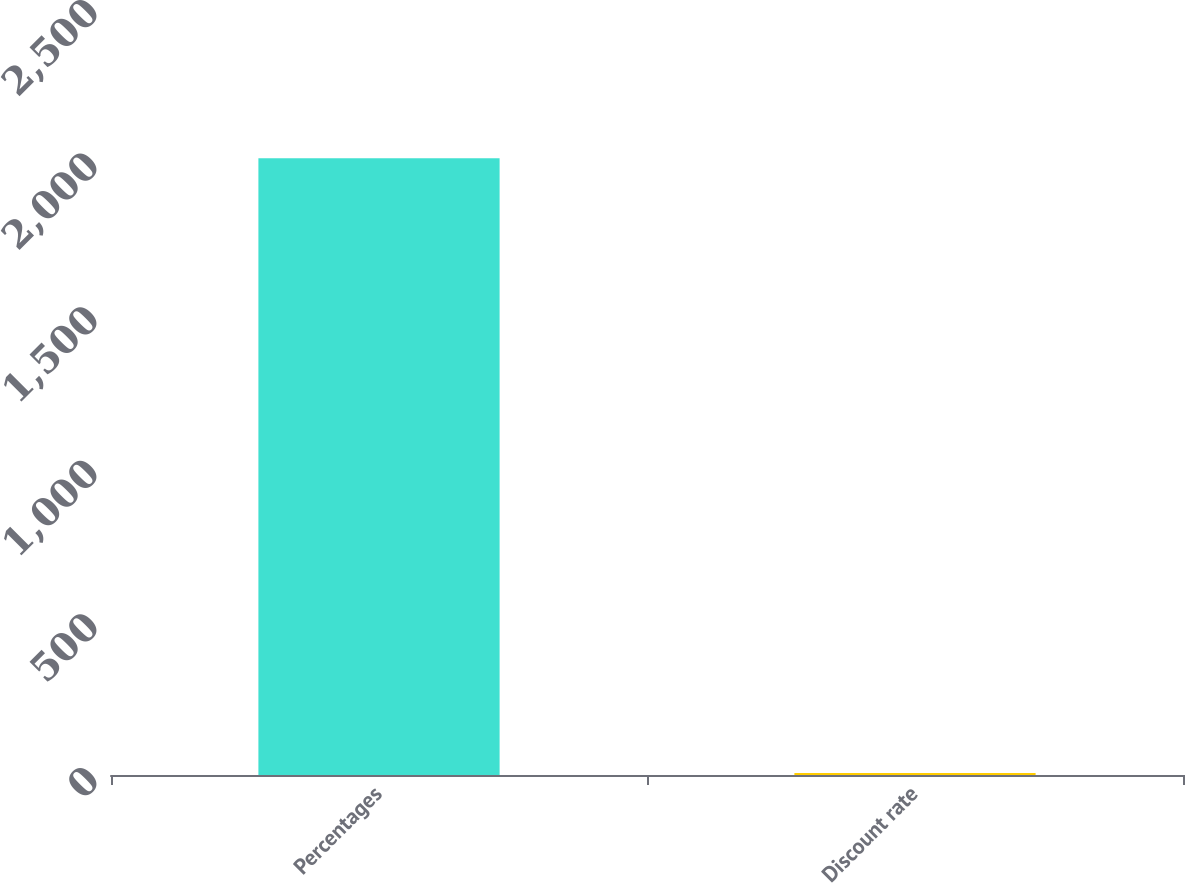Convert chart to OTSL. <chart><loc_0><loc_0><loc_500><loc_500><bar_chart><fcel>Percentages<fcel>Discount rate<nl><fcel>2008<fcel>6.25<nl></chart> 